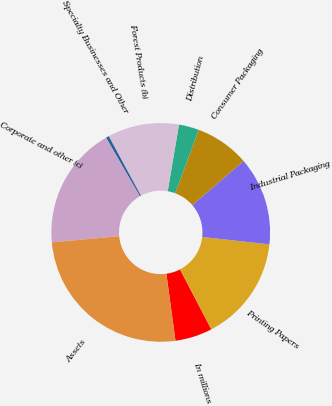Convert chart to OTSL. <chart><loc_0><loc_0><loc_500><loc_500><pie_chart><fcel>In millions<fcel>Printing Papers<fcel>Industrial Packaging<fcel>Consumer Packaging<fcel>Distribution<fcel>Forest Products (b)<fcel>Specialty Businesses and Other<fcel>Corporate and other (c)<fcel>Assets<nl><fcel>5.5%<fcel>15.6%<fcel>13.07%<fcel>8.03%<fcel>2.98%<fcel>10.55%<fcel>0.45%<fcel>18.12%<fcel>25.7%<nl></chart> 